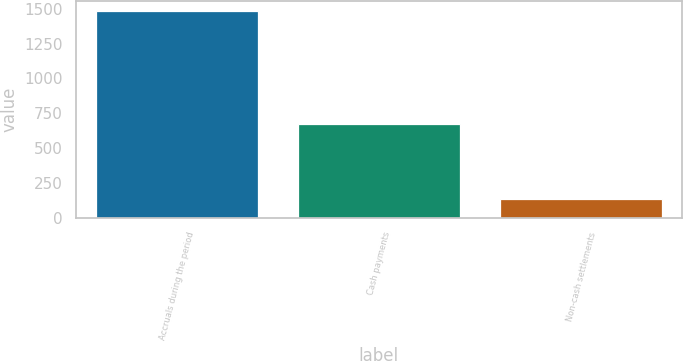<chart> <loc_0><loc_0><loc_500><loc_500><bar_chart><fcel>Accruals during the period<fcel>Cash payments<fcel>Non-cash settlements<nl><fcel>1484<fcel>671<fcel>131<nl></chart> 